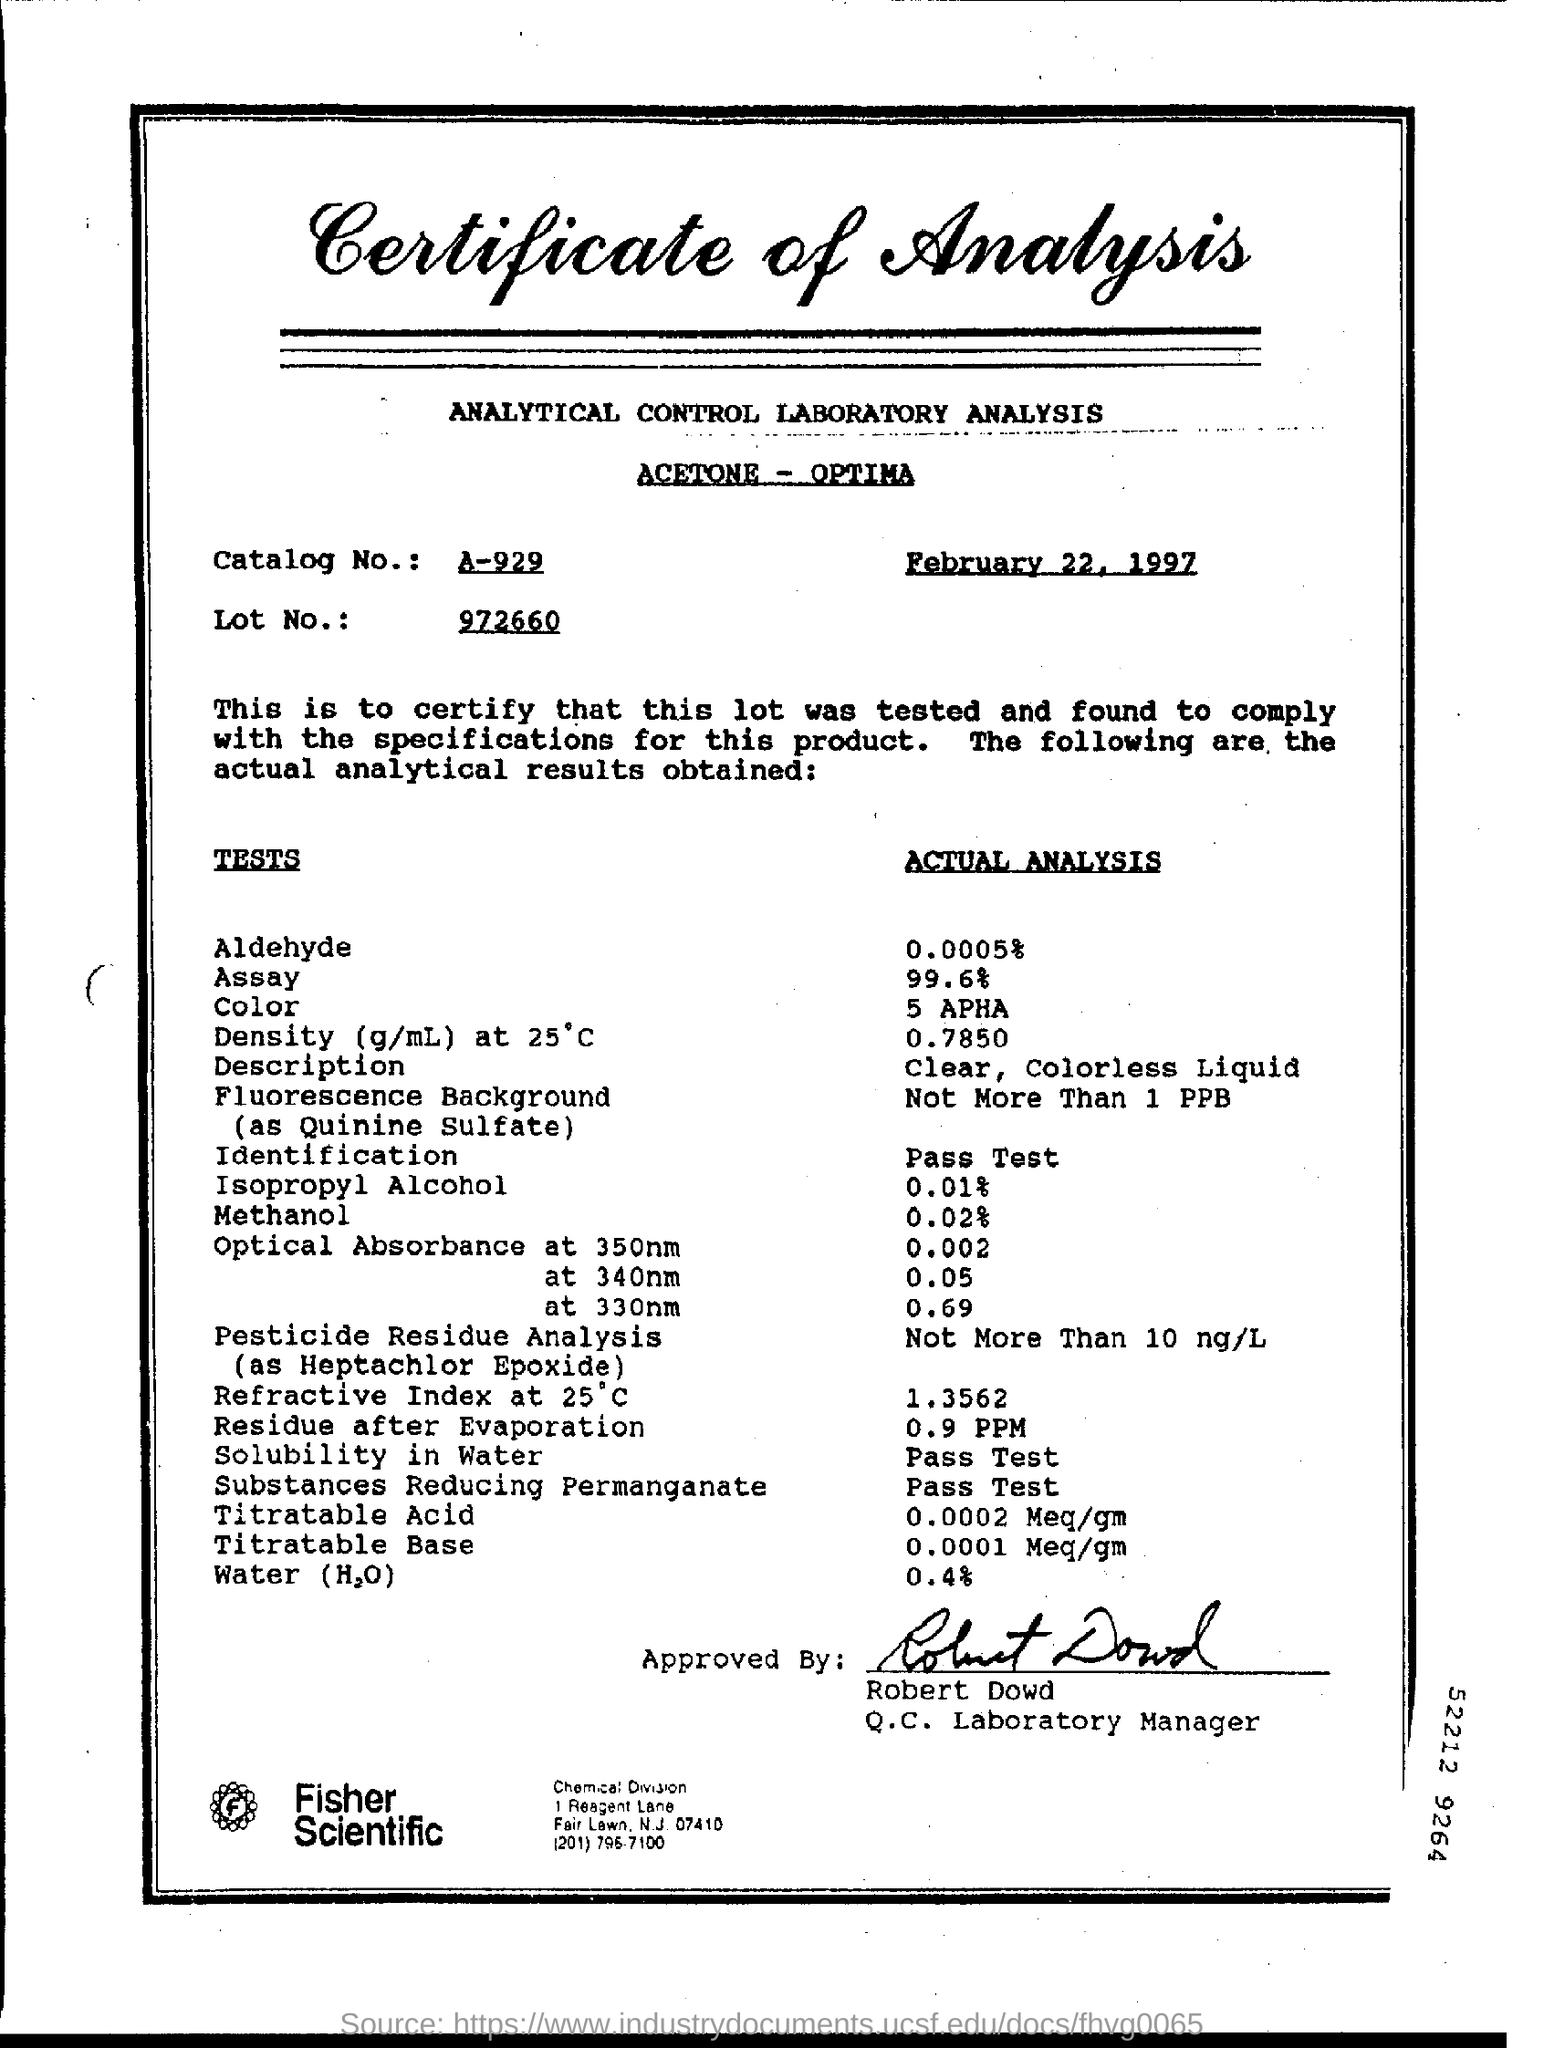Mention a couple of crucial points in this snapshot. It is declared that the signature on the document belongs to Robert Dowd. The actual analysis of water is 0.4%. The document was approved by Robert Dowd. 